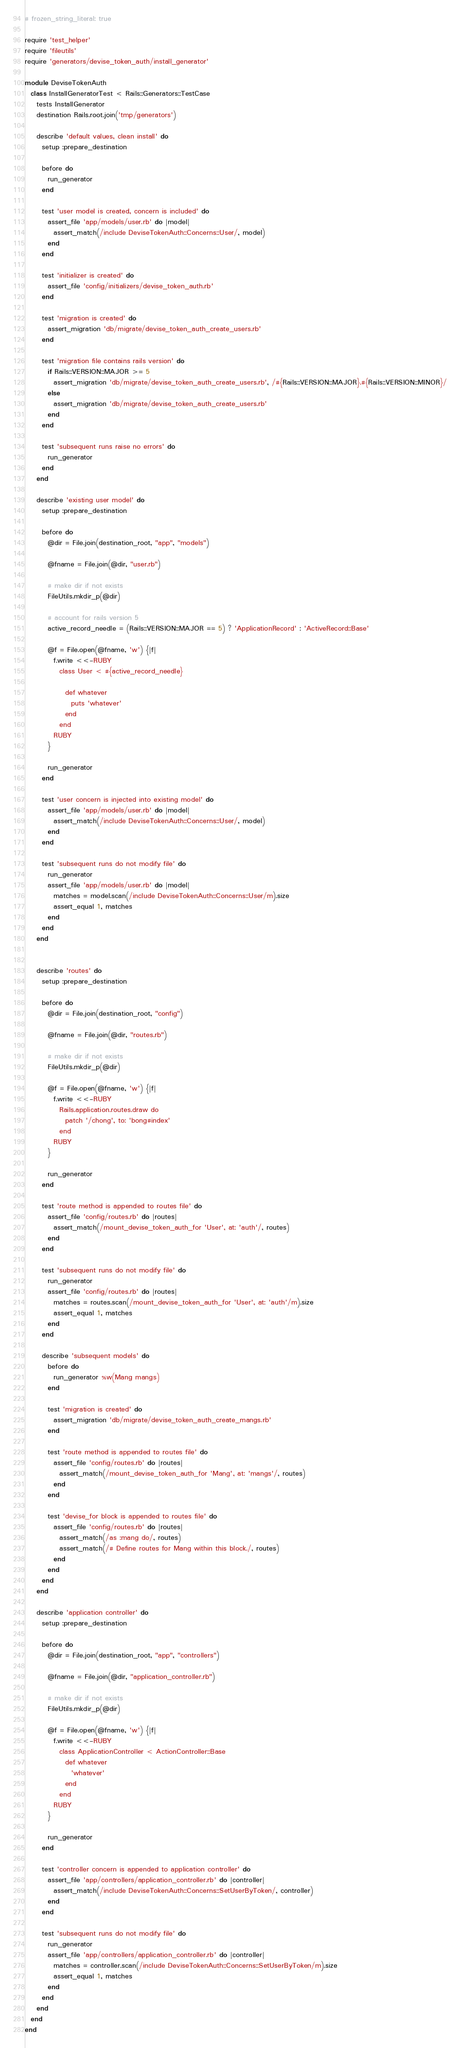Convert code to text. <code><loc_0><loc_0><loc_500><loc_500><_Ruby_># frozen_string_literal: true

require 'test_helper'
require 'fileutils'
require 'generators/devise_token_auth/install_generator'

module DeviseTokenAuth
  class InstallGeneratorTest < Rails::Generators::TestCase
    tests InstallGenerator
    destination Rails.root.join('tmp/generators')

    describe 'default values, clean install' do
      setup :prepare_destination

      before do
        run_generator
      end

      test 'user model is created, concern is included' do
        assert_file 'app/models/user.rb' do |model|
          assert_match(/include DeviseTokenAuth::Concerns::User/, model)
        end
      end

      test 'initializer is created' do
        assert_file 'config/initializers/devise_token_auth.rb'
      end

      test 'migration is created' do
        assert_migration 'db/migrate/devise_token_auth_create_users.rb'
      end

      test 'migration file contains rails version' do
        if Rails::VERSION::MAJOR >= 5
          assert_migration 'db/migrate/devise_token_auth_create_users.rb', /#{Rails::VERSION::MAJOR}.#{Rails::VERSION::MINOR}/
        else
          assert_migration 'db/migrate/devise_token_auth_create_users.rb'
        end
      end

      test 'subsequent runs raise no errors' do
        run_generator
      end
    end

    describe 'existing user model' do
      setup :prepare_destination

      before do
        @dir = File.join(destination_root, "app", "models")

        @fname = File.join(@dir, "user.rb")

        # make dir if not exists
        FileUtils.mkdir_p(@dir)

        # account for rails version 5
        active_record_needle = (Rails::VERSION::MAJOR == 5) ? 'ApplicationRecord' : 'ActiveRecord::Base'

        @f = File.open(@fname, 'w') {|f|
          f.write <<-RUBY
            class User < #{active_record_needle}

              def whatever
                puts 'whatever'
              end
            end
          RUBY
        }

        run_generator
      end

      test 'user concern is injected into existing model' do
        assert_file 'app/models/user.rb' do |model|
          assert_match(/include DeviseTokenAuth::Concerns::User/, model)
        end
      end

      test 'subsequent runs do not modify file' do
        run_generator
        assert_file 'app/models/user.rb' do |model|
          matches = model.scan(/include DeviseTokenAuth::Concerns::User/m).size
          assert_equal 1, matches
        end
      end
    end


    describe 'routes' do
      setup :prepare_destination

      before do
        @dir = File.join(destination_root, "config")

        @fname = File.join(@dir, "routes.rb")

        # make dir if not exists
        FileUtils.mkdir_p(@dir)

        @f = File.open(@fname, 'w') {|f|
          f.write <<-RUBY
            Rails.application.routes.draw do
              patch '/chong', to: 'bong#index'
            end
          RUBY
        }

        run_generator
      end

      test 'route method is appended to routes file' do
        assert_file 'config/routes.rb' do |routes|
          assert_match(/mount_devise_token_auth_for 'User', at: 'auth'/, routes)
        end
      end

      test 'subsequent runs do not modify file' do
        run_generator
        assert_file 'config/routes.rb' do |routes|
          matches = routes.scan(/mount_devise_token_auth_for 'User', at: 'auth'/m).size
          assert_equal 1, matches
        end
      end

      describe 'subsequent models' do
        before do
          run_generator %w(Mang mangs)
        end

        test 'migration is created' do
          assert_migration 'db/migrate/devise_token_auth_create_mangs.rb'
        end

        test 'route method is appended to routes file' do
          assert_file 'config/routes.rb' do |routes|
            assert_match(/mount_devise_token_auth_for 'Mang', at: 'mangs'/, routes)
          end
        end

        test 'devise_for block is appended to routes file' do
          assert_file 'config/routes.rb' do |routes|
            assert_match(/as :mang do/, routes)
            assert_match(/# Define routes for Mang within this block./, routes)
          end
        end
      end
    end

    describe 'application controller' do
      setup :prepare_destination

      before do
        @dir = File.join(destination_root, "app", "controllers")

        @fname = File.join(@dir, "application_controller.rb")

        # make dir if not exists
        FileUtils.mkdir_p(@dir)

        @f = File.open(@fname, 'w') {|f|
          f.write <<-RUBY
            class ApplicationController < ActionController::Base
              def whatever
                'whatever'
              end
            end
          RUBY
        }

        run_generator
      end

      test 'controller concern is appended to application controller' do
        assert_file 'app/controllers/application_controller.rb' do |controller|
          assert_match(/include DeviseTokenAuth::Concerns::SetUserByToken/, controller)
        end
      end

      test 'subsequent runs do not modify file' do
        run_generator
        assert_file 'app/controllers/application_controller.rb' do |controller|
          matches = controller.scan(/include DeviseTokenAuth::Concerns::SetUserByToken/m).size
          assert_equal 1, matches
        end
      end
    end
  end
end
</code> 